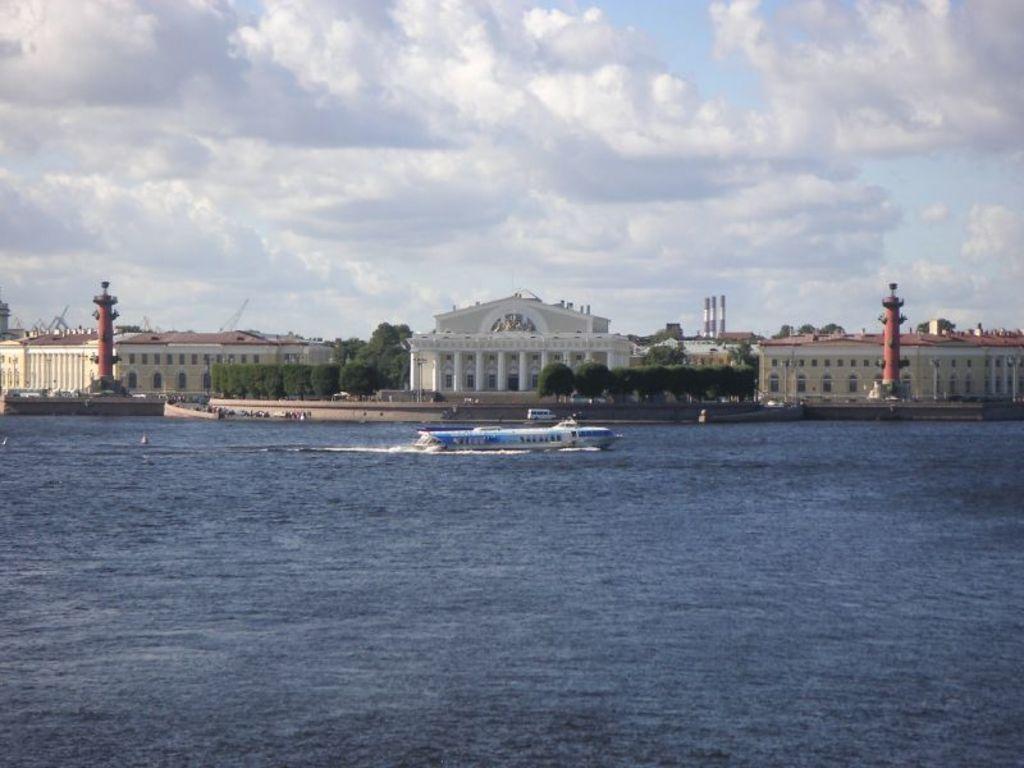Please provide a concise description of this image. In this picture we can see a boat on water and in the background we can see buildings, trees, vehicle, sky with clouds and some objects. 